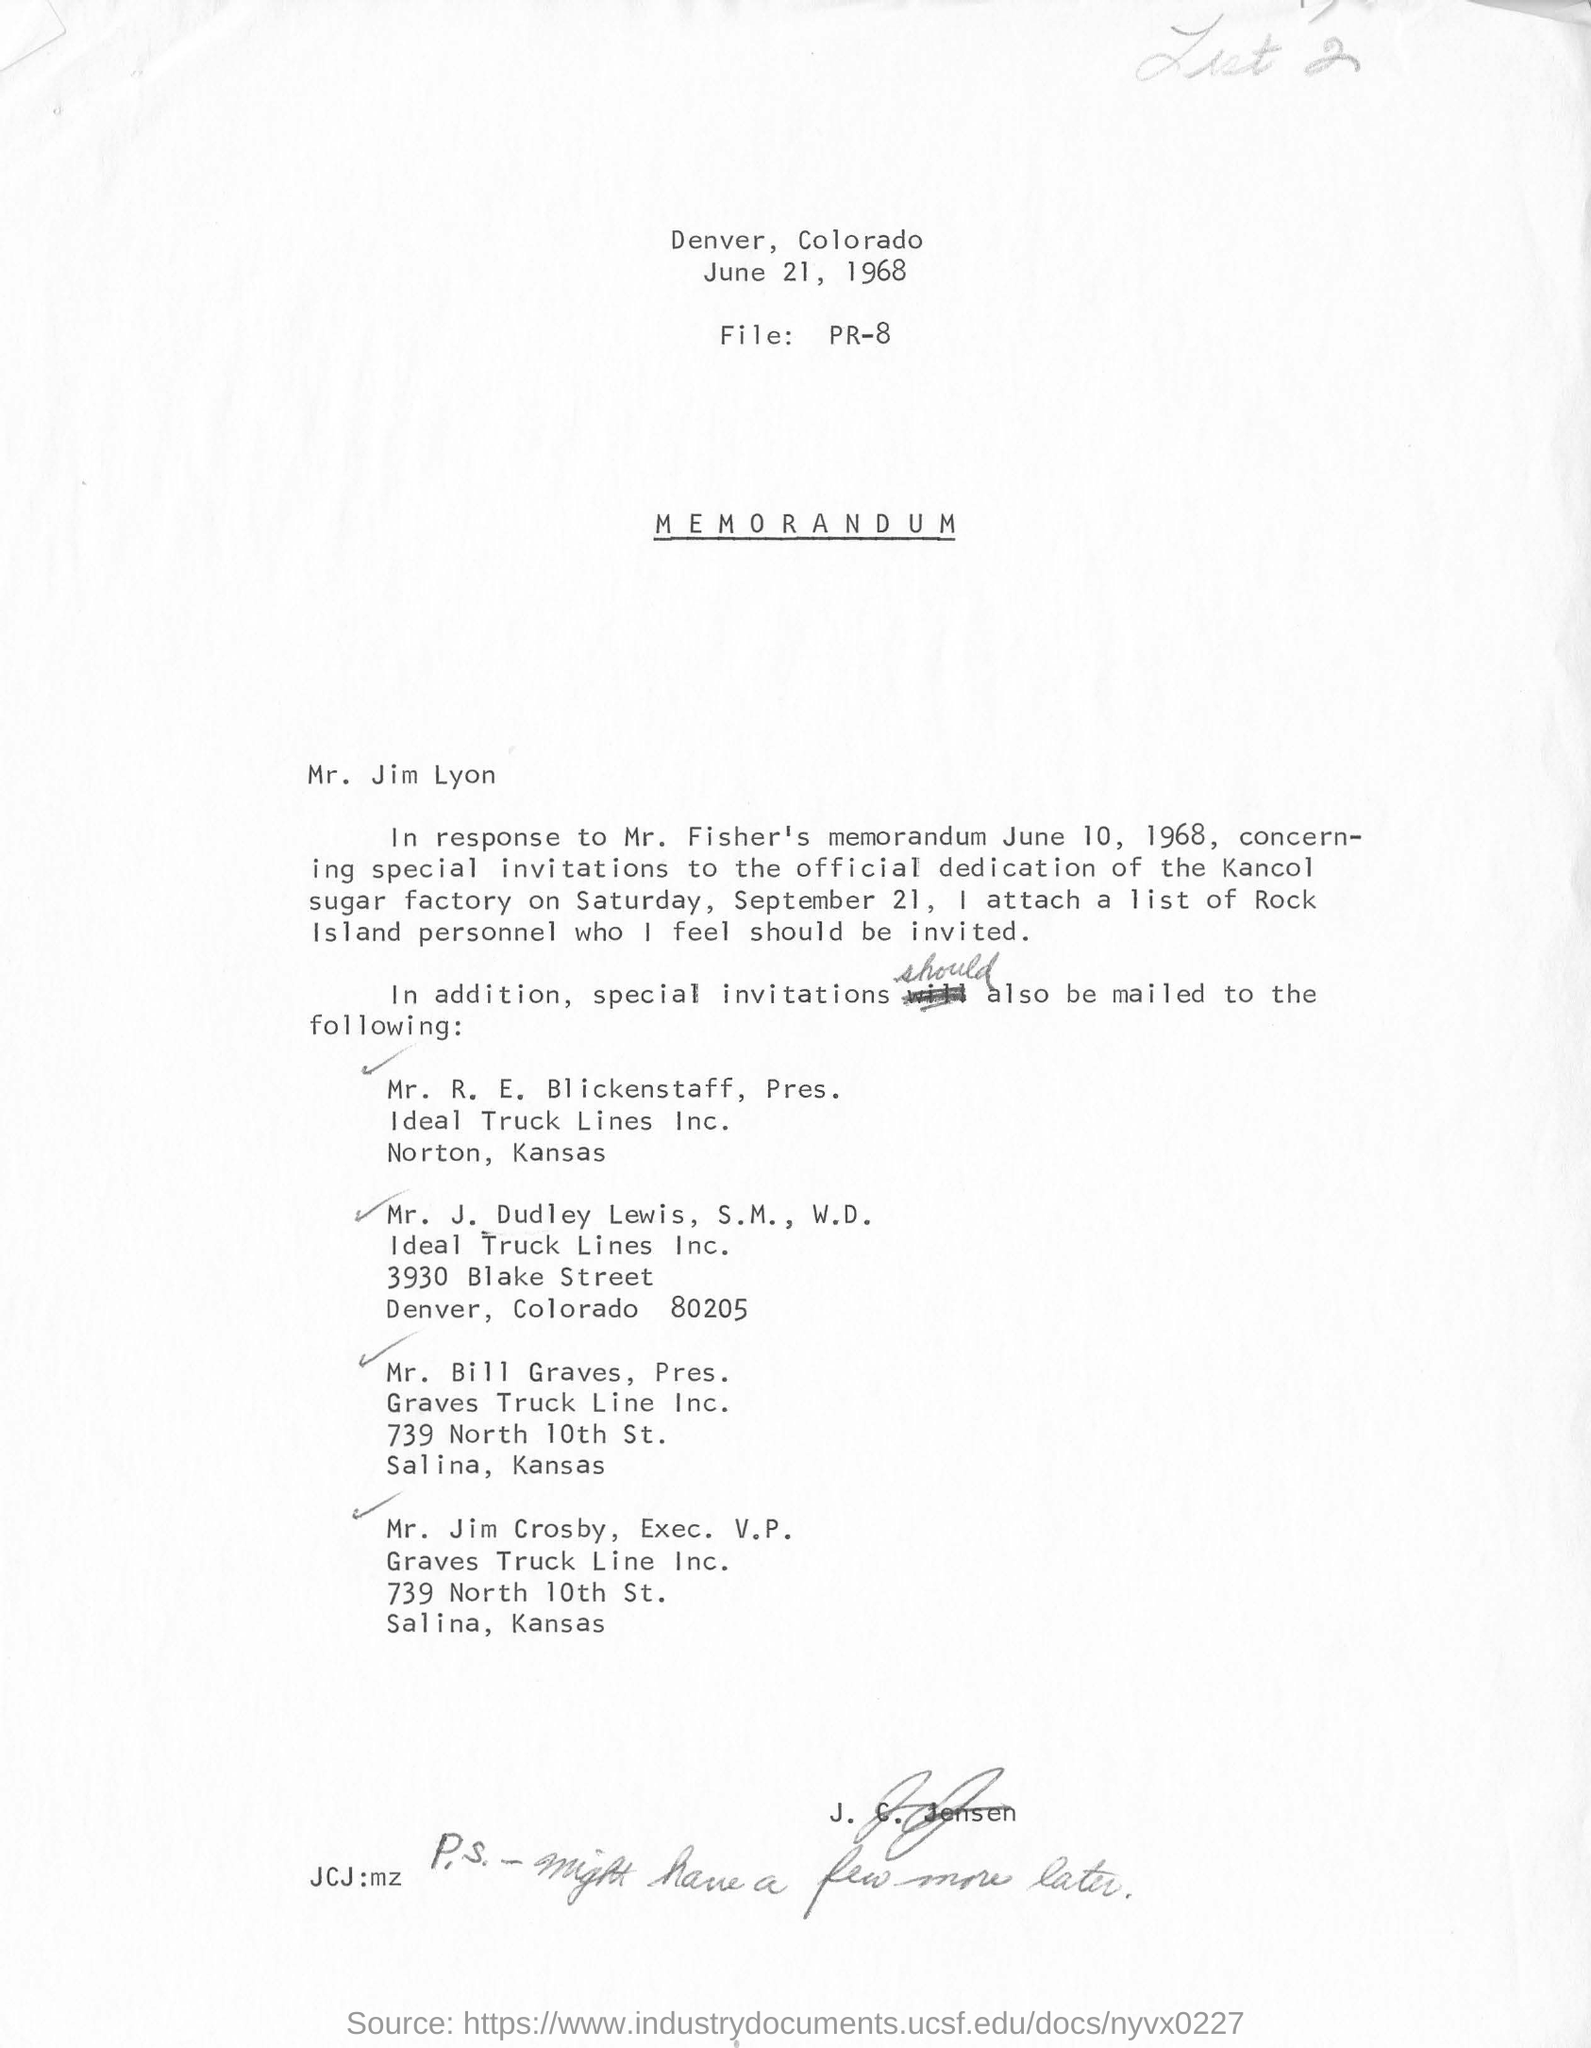List a handful of essential elements in this visual. The date at the top of the page is June 21, 1968. Denver is located in the state of Colorado. 